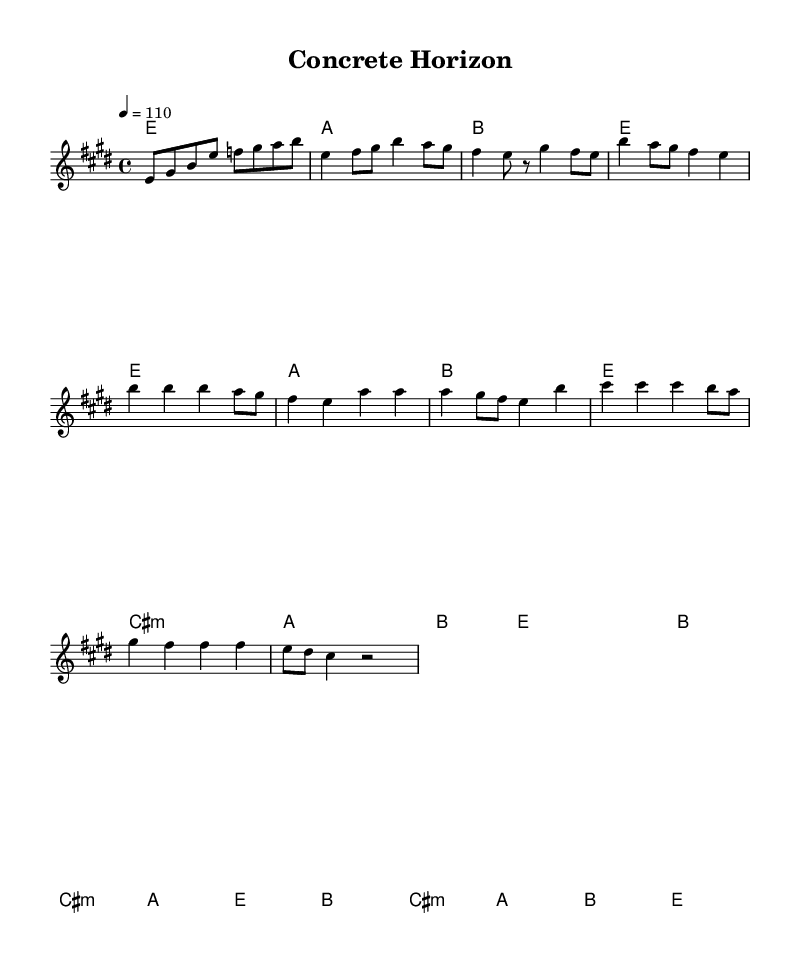What is the key signature of this music? The key signature shows that the music is in E major, which has four sharps (F#, C#, G#, and D#). This is determined by looking at the key signature indicated at the beginning of the score.
Answer: E major What is the time signature of this piece? The time signature is shown at the beginning of the score, indicating that there are four beats per measure. It is represented as a fraction with a 4 on top and a 4 on the bottom.
Answer: 4/4 What is the tempo marking of the piece? The tempo marking is provided in the score, indicating the speed of the music. It states a tempo of 110 beats per minute. This is found in the tempo indication that is placed in the global section.
Answer: 110 How many measures are in the chorus section? To find the number of measures in the chorus, we can look at the section designated as the chorus within the melody and harmonies. Counting each bar within that section, we find there are four measures.
Answer: 4 What type of chord is used in the bridge? The bridge section indicates the use of a minor chord for the first chord which is designated as cis:m, meaning C# minor. This is evident in the chord symbols provided in the harmonies section.
Answer: C# minor Which musical form is primarily used in this piece? The structure of the piece can be analyzed by identifying the sections present in the music. The presence of verses, a chorus, and a bridge indicates a common verse-chorus form. This can be inferred from the arrangement and labeling of the sections in the score.
Answer: Verse-chorus form 